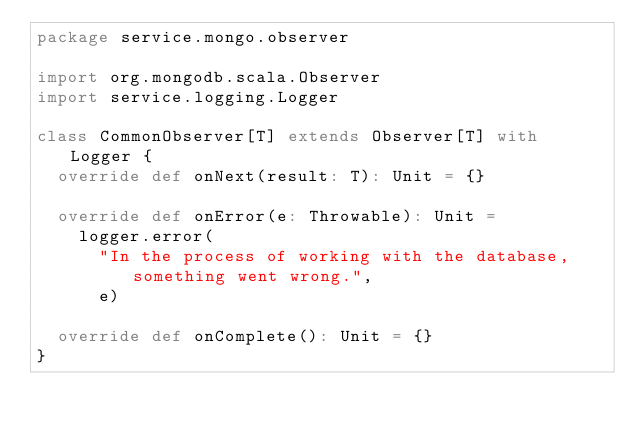Convert code to text. <code><loc_0><loc_0><loc_500><loc_500><_Scala_>package service.mongo.observer

import org.mongodb.scala.Observer
import service.logging.Logger

class CommonObserver[T] extends Observer[T] with Logger {
  override def onNext(result: T): Unit = {}

  override def onError(e: Throwable): Unit =
    logger.error(
      "In the process of working with the database, something went wrong.",
      e)

  override def onComplete(): Unit = {}
}
</code> 